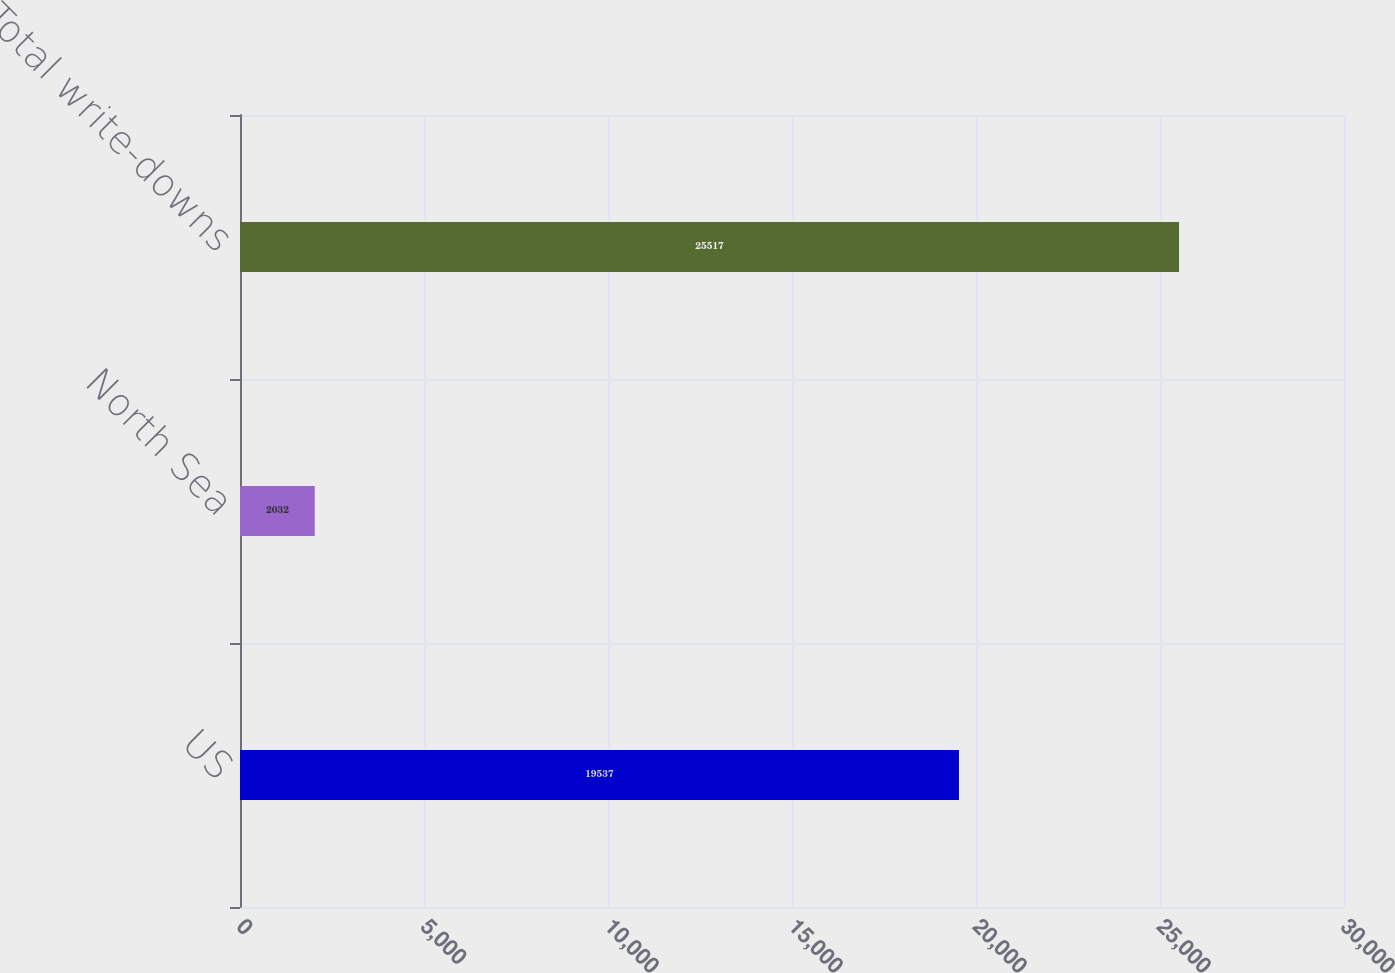Convert chart to OTSL. <chart><loc_0><loc_0><loc_500><loc_500><bar_chart><fcel>US<fcel>North Sea<fcel>Total write-downs<nl><fcel>19537<fcel>2032<fcel>25517<nl></chart> 